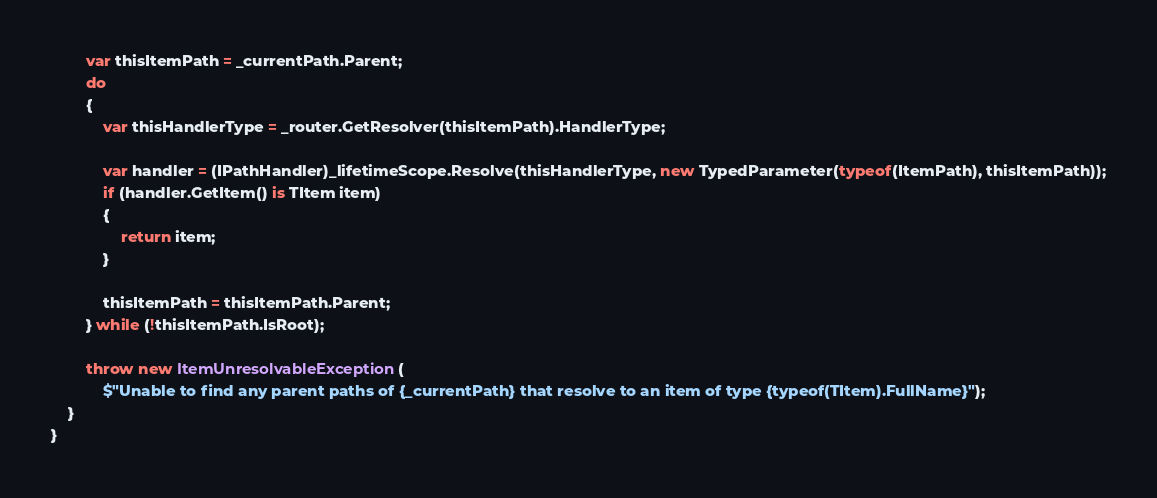Convert code to text. <code><loc_0><loc_0><loc_500><loc_500><_C#_>        var thisItemPath = _currentPath.Parent;
        do
        {
            var thisHandlerType = _router.GetResolver(thisItemPath).HandlerType;

            var handler = (IPathHandler)_lifetimeScope.Resolve(thisHandlerType, new TypedParameter(typeof(ItemPath), thisItemPath));
            if (handler.GetItem() is TItem item)
            {
                return item;
            }

            thisItemPath = thisItemPath.Parent;
        } while (!thisItemPath.IsRoot);

        throw new ItemUnresolvableException(
            $"Unable to find any parent paths of {_currentPath} that resolve to an item of type {typeof(TItem).FullName}");
    }
}</code> 